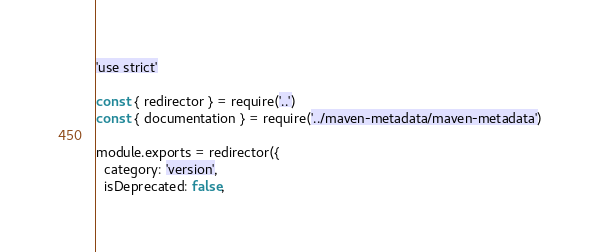<code> <loc_0><loc_0><loc_500><loc_500><_JavaScript_>'use strict'

const { redirector } = require('..')
const { documentation } = require('../maven-metadata/maven-metadata')

module.exports = redirector({
  category: 'version',
  isDeprecated: false,</code> 